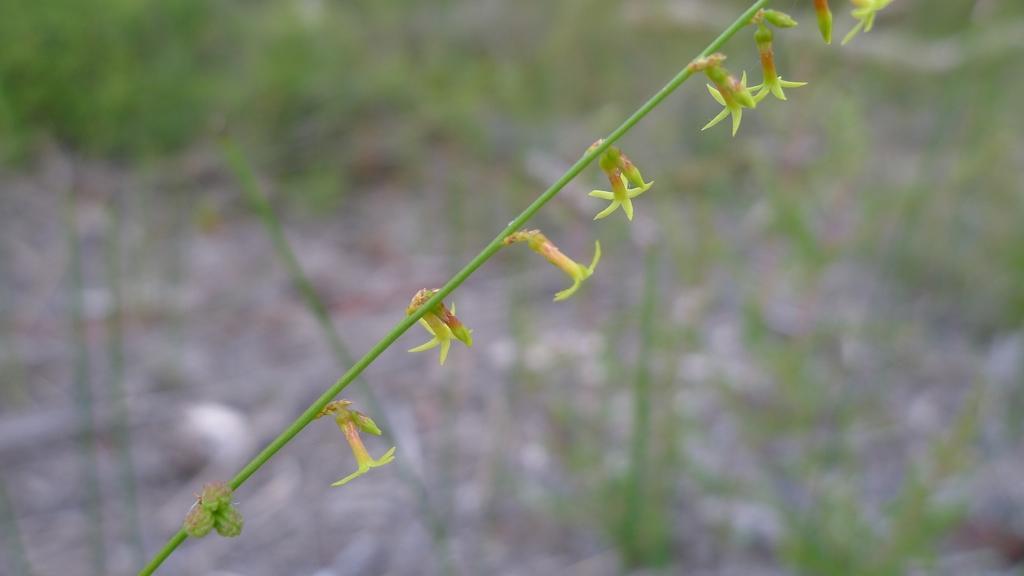How would you summarize this image in a sentence or two? In the foreground of this image, there are few flowers to the creeper and the background is blurred. 